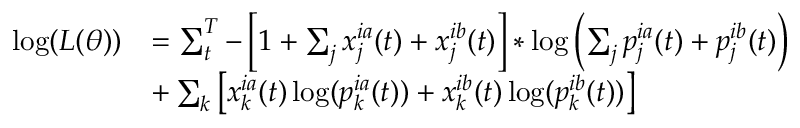Convert formula to latex. <formula><loc_0><loc_0><loc_500><loc_500>\begin{array} { r l } { \log ( L ( \theta ) ) } & { = \sum _ { t } ^ { T } - \left [ 1 + \sum _ { j } x _ { j } ^ { i a } ( t ) + x _ { j } ^ { i b } ( t ) \right ] * \log \left ( \sum _ { j } p _ { j } ^ { i a } ( t ) + p _ { j } ^ { i b } ( t ) \right ) } \\ & { + \sum _ { k } \left [ x _ { k } ^ { i a } ( t ) \log ( p _ { k } ^ { i a } ( t ) ) + x _ { k } ^ { i b } ( t ) \log ( p _ { k } ^ { i b } ( t ) ) \right ] } \end{array}</formula> 